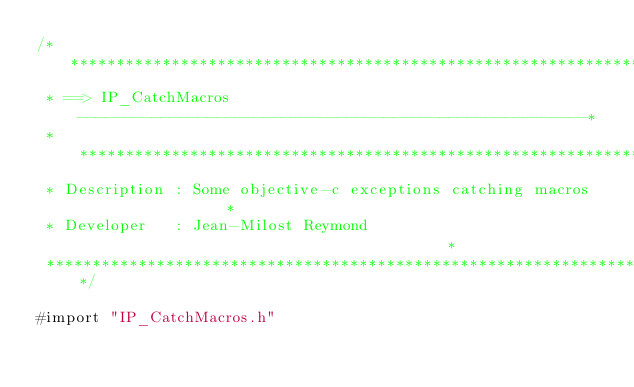<code> <loc_0><loc_0><loc_500><loc_500><_ObjectiveC_>/*****************************************************************************
 * ==> IP_CatchMacros -------------------------------------------------------*
 * ***************************************************************************
 * Description : Some objective-c exceptions catching macros                 *
 * Developer   : Jean-Milost Reymond                                         *
 *****************************************************************************/

#import "IP_CatchMacros.h"
</code> 